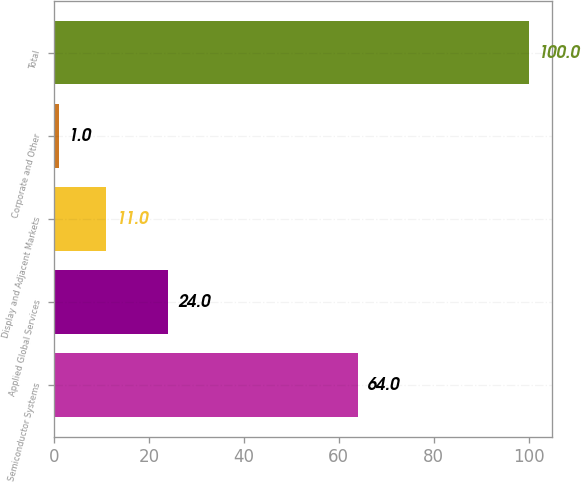Convert chart. <chart><loc_0><loc_0><loc_500><loc_500><bar_chart><fcel>Semiconductor Systems<fcel>Applied Global Services<fcel>Display and Adjacent Markets<fcel>Corporate and Other<fcel>Total<nl><fcel>64<fcel>24<fcel>11<fcel>1<fcel>100<nl></chart> 